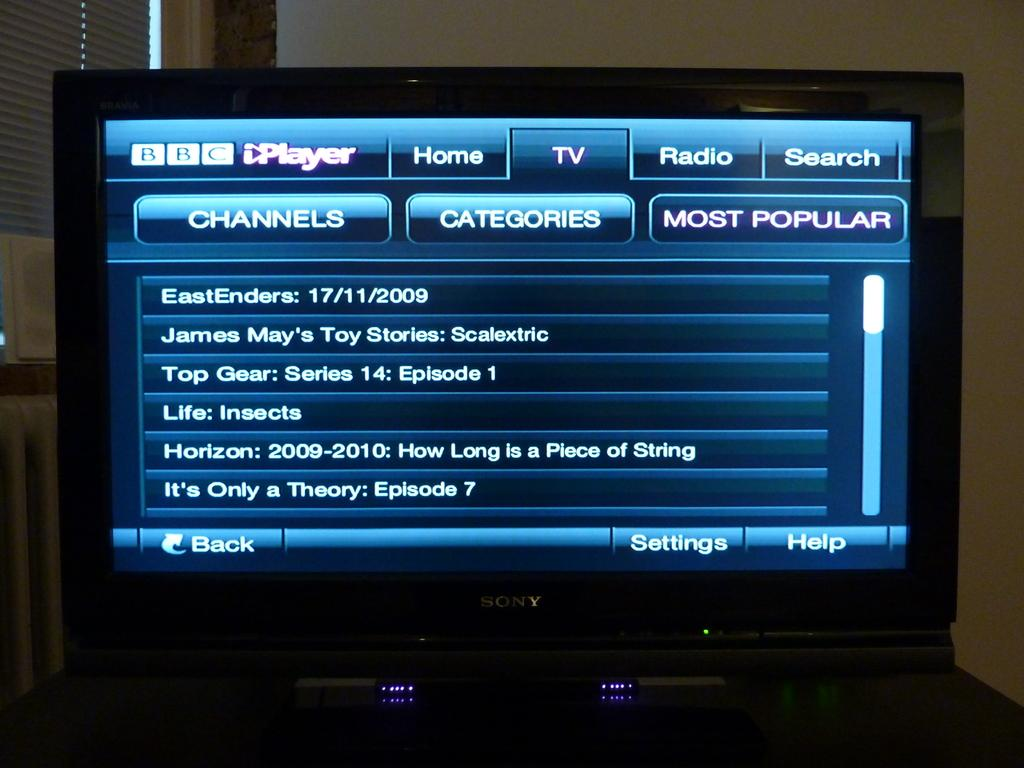<image>
Create a compact narrative representing the image presented. The BBC video player displays three separate columns called Channels, Categories and Most Popular. 